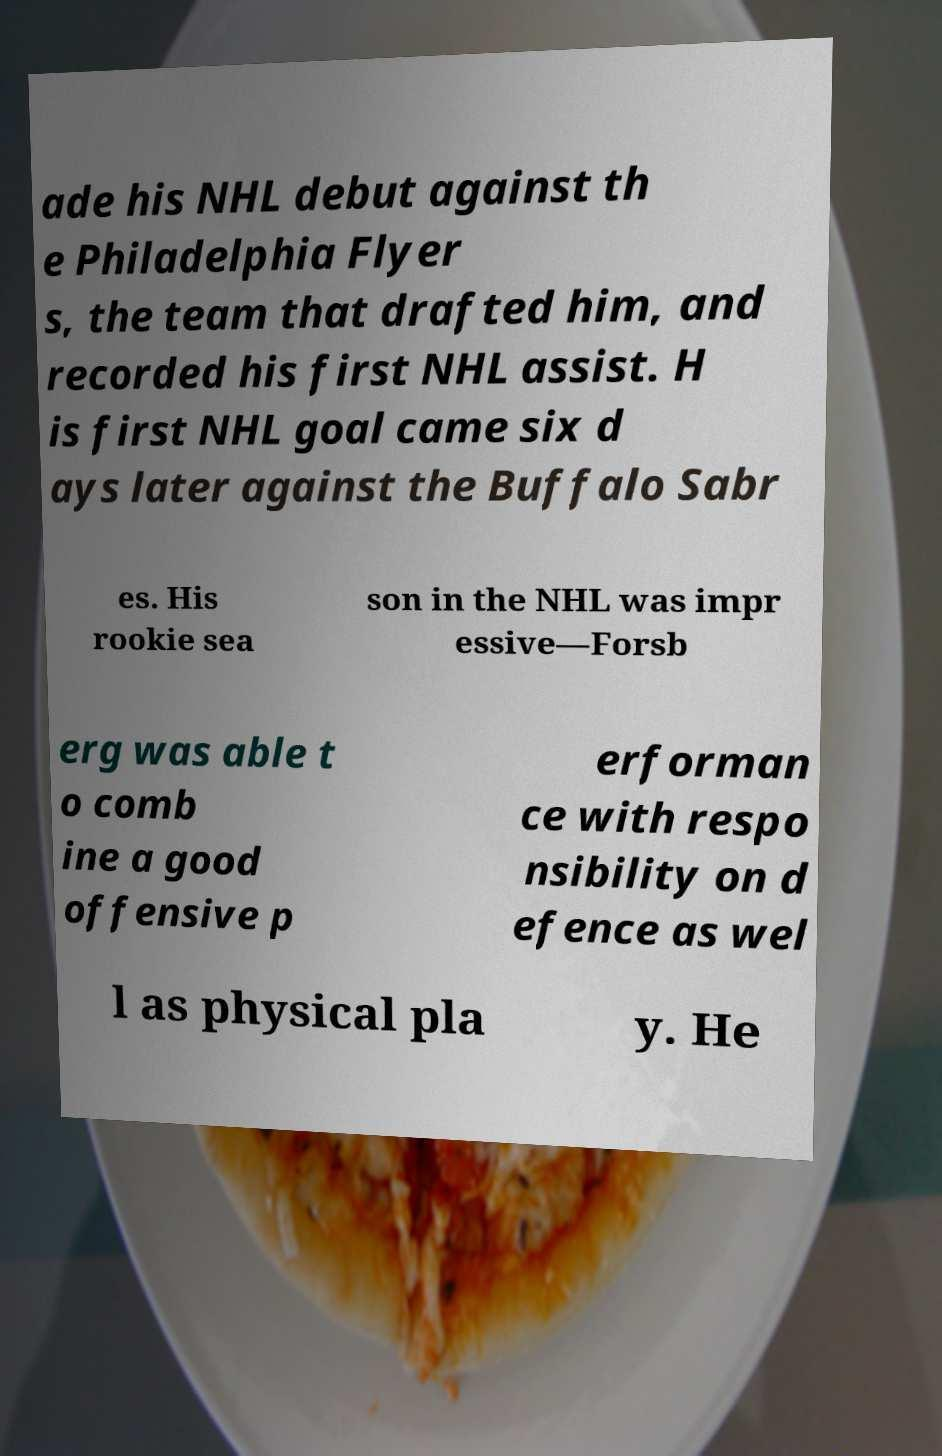Could you assist in decoding the text presented in this image and type it out clearly? ade his NHL debut against th e Philadelphia Flyer s, the team that drafted him, and recorded his first NHL assist. H is first NHL goal came six d ays later against the Buffalo Sabr es. His rookie sea son in the NHL was impr essive—Forsb erg was able t o comb ine a good offensive p erforman ce with respo nsibility on d efence as wel l as physical pla y. He 